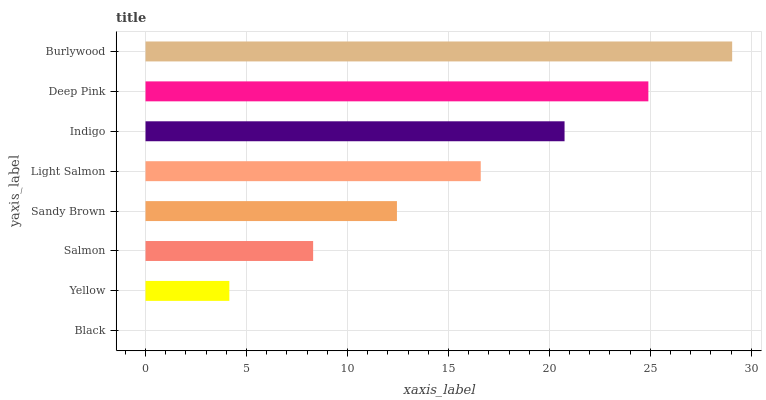Is Black the minimum?
Answer yes or no. Yes. Is Burlywood the maximum?
Answer yes or no. Yes. Is Yellow the minimum?
Answer yes or no. No. Is Yellow the maximum?
Answer yes or no. No. Is Yellow greater than Black?
Answer yes or no. Yes. Is Black less than Yellow?
Answer yes or no. Yes. Is Black greater than Yellow?
Answer yes or no. No. Is Yellow less than Black?
Answer yes or no. No. Is Light Salmon the high median?
Answer yes or no. Yes. Is Sandy Brown the low median?
Answer yes or no. Yes. Is Yellow the high median?
Answer yes or no. No. Is Burlywood the low median?
Answer yes or no. No. 